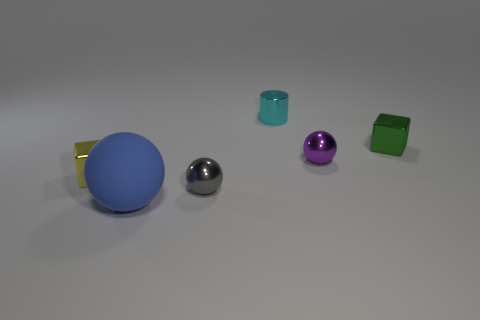Is the gray thing the same size as the blue thing?
Your answer should be compact. No. How many objects are either shiny objects on the right side of the small gray metal sphere or objects that are in front of the green object?
Offer a very short reply. 6. What is the material of the tiny sphere behind the metal object left of the large object?
Ensure brevity in your answer.  Metal. How many other objects are the same material as the large sphere?
Offer a very short reply. 0. Is the shape of the blue object the same as the tiny purple shiny object?
Make the answer very short. Yes. There is a matte object that is to the right of the yellow metallic block; what size is it?
Provide a succinct answer. Large. There is a cyan cylinder; is it the same size as the object that is in front of the gray ball?
Make the answer very short. No. Are there fewer cylinders that are on the left side of the yellow object than yellow shiny cubes?
Provide a short and direct response. Yes. What material is the other tiny object that is the same shape as the small purple shiny object?
Offer a terse response. Metal. The small metallic thing that is behind the small purple object and on the left side of the small green metal object has what shape?
Your answer should be very brief. Cylinder. 